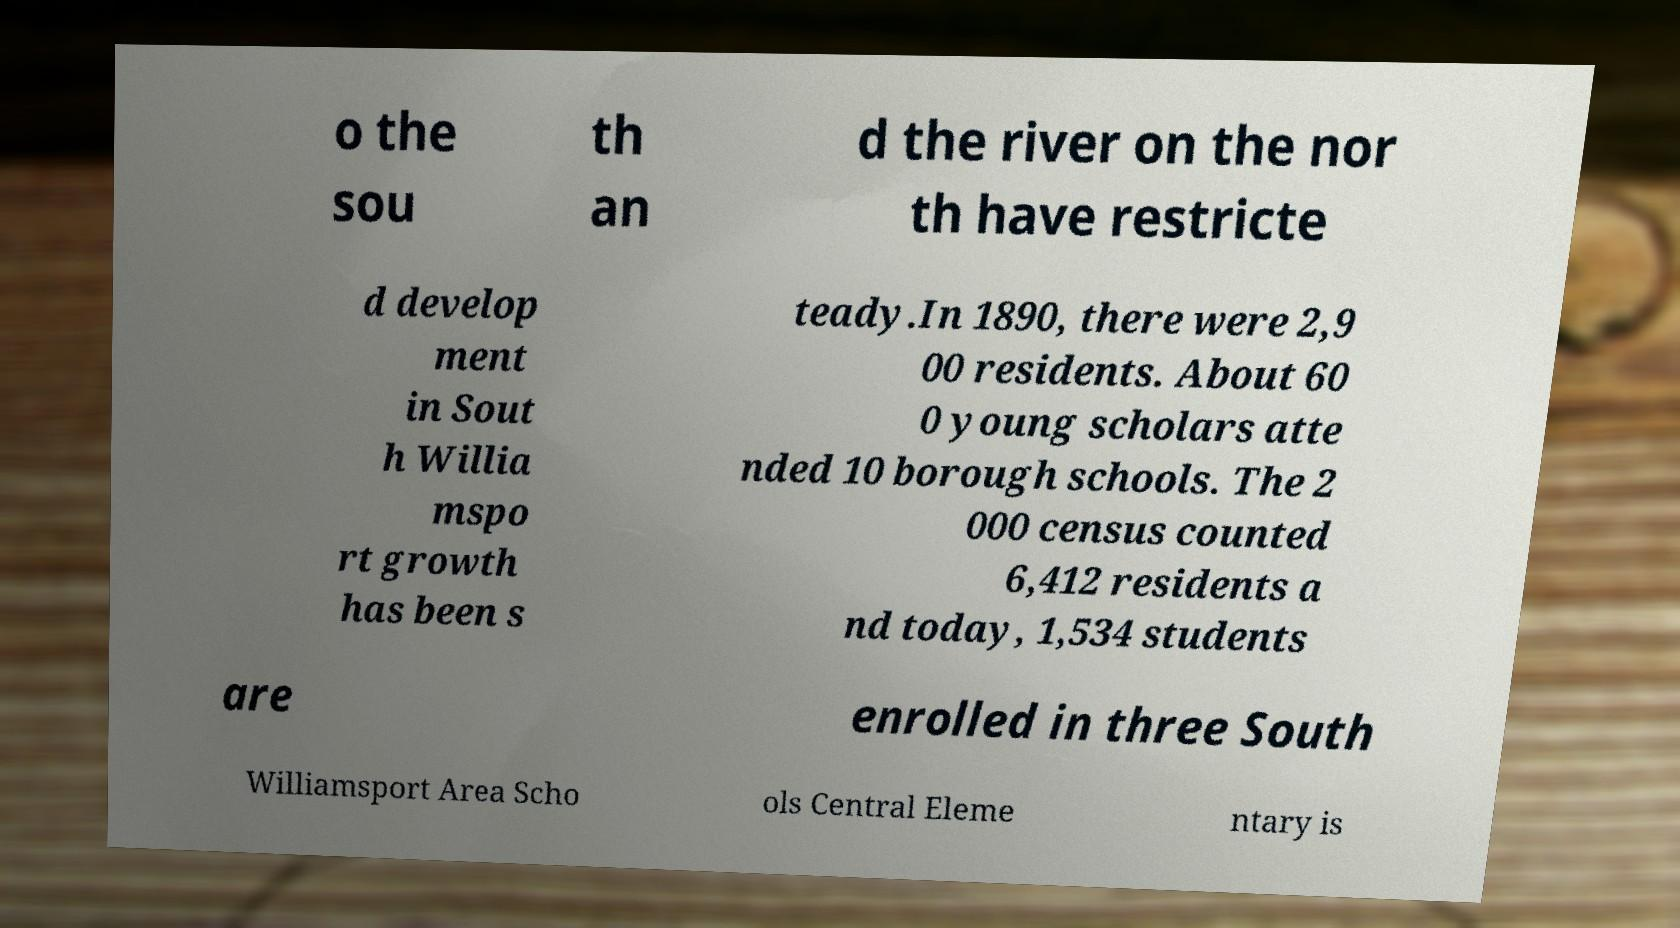Can you accurately transcribe the text from the provided image for me? o the sou th an d the river on the nor th have restricte d develop ment in Sout h Willia mspo rt growth has been s teady.In 1890, there were 2,9 00 residents. About 60 0 young scholars atte nded 10 borough schools. The 2 000 census counted 6,412 residents a nd today, 1,534 students are enrolled in three South Williamsport Area Scho ols Central Eleme ntary is 